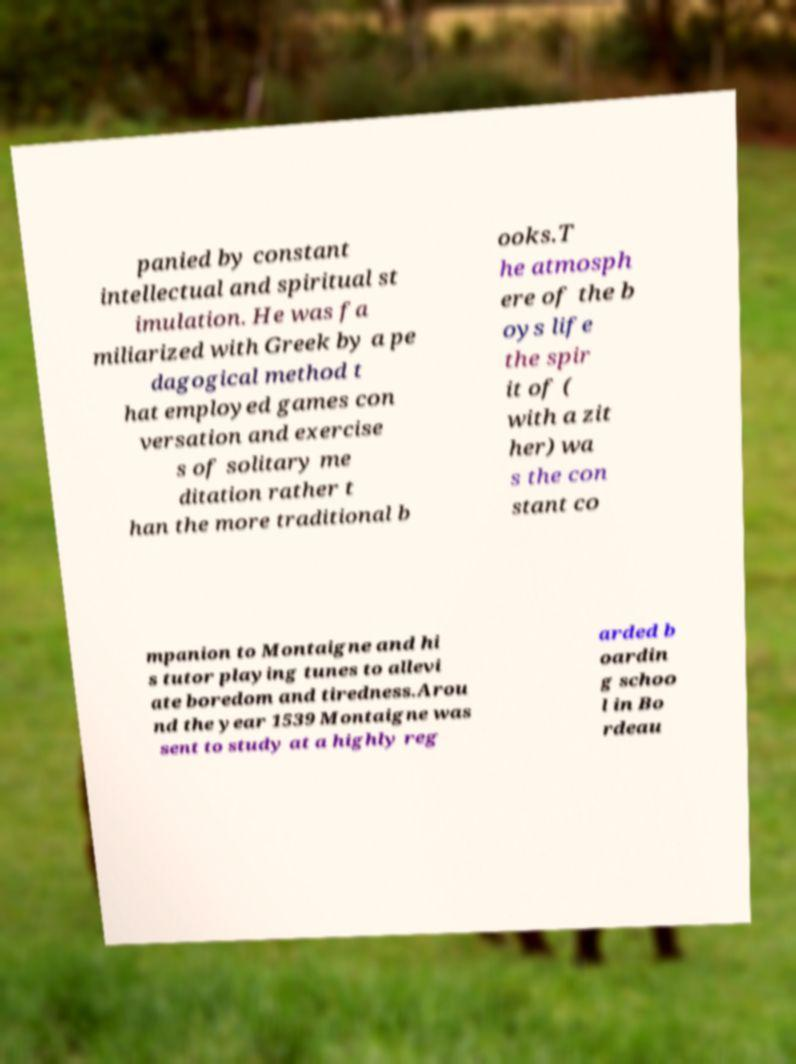I need the written content from this picture converted into text. Can you do that? panied by constant intellectual and spiritual st imulation. He was fa miliarized with Greek by a pe dagogical method t hat employed games con versation and exercise s of solitary me ditation rather t han the more traditional b ooks.T he atmosph ere of the b oys life the spir it of ( with a zit her) wa s the con stant co mpanion to Montaigne and hi s tutor playing tunes to allevi ate boredom and tiredness.Arou nd the year 1539 Montaigne was sent to study at a highly reg arded b oardin g schoo l in Bo rdeau 